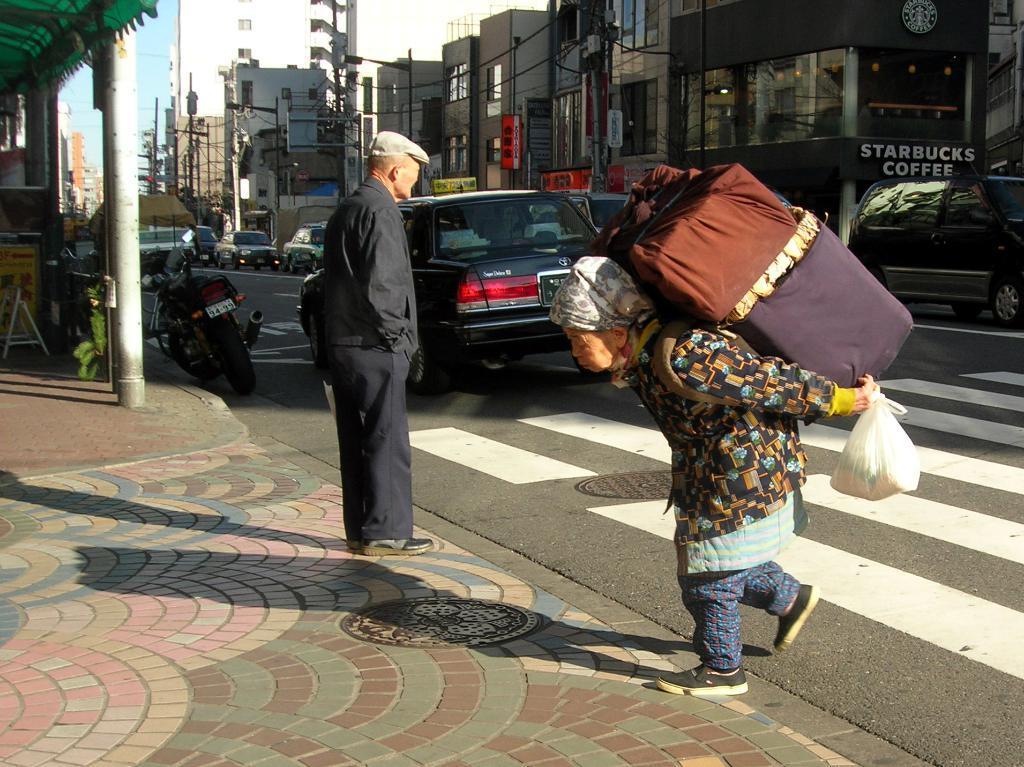How would you summarize this image in a sentence or two? In this image there is the sky, there are buildings, there is a person standing, there is a person walking, there is a person holding objects, there is a road, there are vehicles on the road, there is a vehicle truncated towards the right of the image, there are shops, there is a building truncated towards the right of the image, there is a building truncated towards the left of the image, there is an object on the ground. 